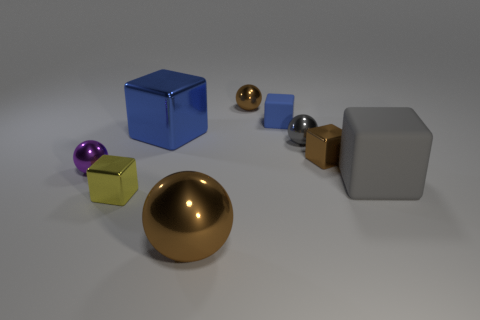What is the size of the matte thing that is the same color as the large metallic block?
Offer a terse response. Small. What material is the block that is the same color as the small matte thing?
Make the answer very short. Metal. Is the color of the small rubber block the same as the big metallic cube?
Your response must be concise. Yes. What is the tiny block that is on the left side of the brown metal cube and behind the large matte cube made of?
Keep it short and to the point. Rubber. The large metal ball has what color?
Provide a succinct answer. Brown. What number of other large metal things have the same shape as the big brown thing?
Make the answer very short. 0. Are the blue block to the right of the big brown metal ball and the large block that is in front of the tiny purple metal sphere made of the same material?
Make the answer very short. Yes. There is a matte cube that is in front of the large block to the left of the big brown metallic object; how big is it?
Offer a very short reply. Large. What is the material of the tiny blue thing that is the same shape as the big gray object?
Make the answer very short. Rubber. Do the object behind the small matte cube and the small metal object to the left of the small yellow shiny thing have the same shape?
Your answer should be compact. Yes. 